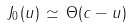Convert formula to latex. <formula><loc_0><loc_0><loc_500><loc_500>J _ { 0 } ( u ) \, \simeq \, \Theta ( c - u )</formula> 